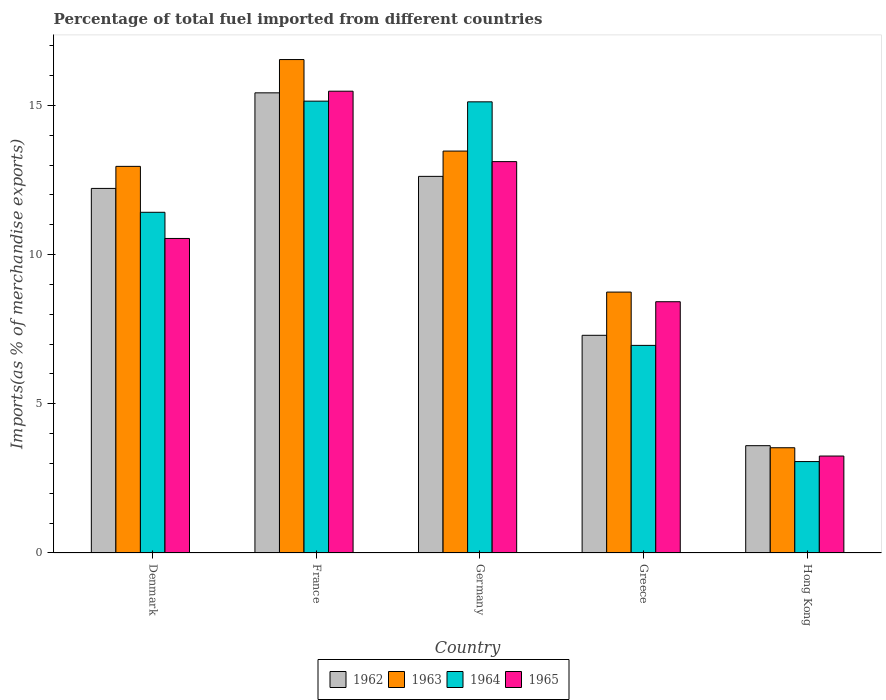How many different coloured bars are there?
Ensure brevity in your answer.  4. How many groups of bars are there?
Provide a succinct answer. 5. Are the number of bars per tick equal to the number of legend labels?
Your answer should be very brief. Yes. What is the label of the 4th group of bars from the left?
Provide a succinct answer. Greece. What is the percentage of imports to different countries in 1962 in Greece?
Your response must be concise. 7.3. Across all countries, what is the maximum percentage of imports to different countries in 1962?
Ensure brevity in your answer.  15.42. Across all countries, what is the minimum percentage of imports to different countries in 1965?
Keep it short and to the point. 3.25. In which country was the percentage of imports to different countries in 1962 maximum?
Provide a short and direct response. France. In which country was the percentage of imports to different countries in 1964 minimum?
Your answer should be very brief. Hong Kong. What is the total percentage of imports to different countries in 1963 in the graph?
Provide a short and direct response. 55.24. What is the difference between the percentage of imports to different countries in 1962 in Denmark and that in Hong Kong?
Your response must be concise. 8.62. What is the difference between the percentage of imports to different countries in 1964 in Greece and the percentage of imports to different countries in 1962 in Germany?
Offer a terse response. -5.66. What is the average percentage of imports to different countries in 1964 per country?
Give a very brief answer. 10.34. What is the difference between the percentage of imports to different countries of/in 1964 and percentage of imports to different countries of/in 1962 in France?
Your answer should be very brief. -0.28. In how many countries, is the percentage of imports to different countries in 1963 greater than 14 %?
Offer a terse response. 1. What is the ratio of the percentage of imports to different countries in 1963 in Greece to that in Hong Kong?
Provide a short and direct response. 2.48. Is the difference between the percentage of imports to different countries in 1964 in Denmark and Greece greater than the difference between the percentage of imports to different countries in 1962 in Denmark and Greece?
Your answer should be very brief. No. What is the difference between the highest and the second highest percentage of imports to different countries in 1964?
Ensure brevity in your answer.  -3.7. What is the difference between the highest and the lowest percentage of imports to different countries in 1962?
Give a very brief answer. 11.83. In how many countries, is the percentage of imports to different countries in 1962 greater than the average percentage of imports to different countries in 1962 taken over all countries?
Ensure brevity in your answer.  3. What does the 3rd bar from the left in Greece represents?
Your answer should be compact. 1964. What does the 2nd bar from the right in Denmark represents?
Give a very brief answer. 1964. Is it the case that in every country, the sum of the percentage of imports to different countries in 1963 and percentage of imports to different countries in 1962 is greater than the percentage of imports to different countries in 1964?
Your answer should be compact. Yes. Are all the bars in the graph horizontal?
Your answer should be very brief. No. Are the values on the major ticks of Y-axis written in scientific E-notation?
Ensure brevity in your answer.  No. Does the graph contain grids?
Your answer should be very brief. No. How many legend labels are there?
Make the answer very short. 4. How are the legend labels stacked?
Your response must be concise. Horizontal. What is the title of the graph?
Make the answer very short. Percentage of total fuel imported from different countries. What is the label or title of the X-axis?
Your response must be concise. Country. What is the label or title of the Y-axis?
Provide a short and direct response. Imports(as % of merchandise exports). What is the Imports(as % of merchandise exports) of 1962 in Denmark?
Your answer should be very brief. 12.22. What is the Imports(as % of merchandise exports) of 1963 in Denmark?
Give a very brief answer. 12.96. What is the Imports(as % of merchandise exports) in 1964 in Denmark?
Your response must be concise. 11.42. What is the Imports(as % of merchandise exports) of 1965 in Denmark?
Your response must be concise. 10.54. What is the Imports(as % of merchandise exports) in 1962 in France?
Provide a succinct answer. 15.42. What is the Imports(as % of merchandise exports) in 1963 in France?
Provide a short and direct response. 16.54. What is the Imports(as % of merchandise exports) in 1964 in France?
Your response must be concise. 15.14. What is the Imports(as % of merchandise exports) of 1965 in France?
Offer a terse response. 15.48. What is the Imports(as % of merchandise exports) of 1962 in Germany?
Make the answer very short. 12.62. What is the Imports(as % of merchandise exports) in 1963 in Germany?
Give a very brief answer. 13.47. What is the Imports(as % of merchandise exports) in 1964 in Germany?
Ensure brevity in your answer.  15.12. What is the Imports(as % of merchandise exports) in 1965 in Germany?
Offer a terse response. 13.12. What is the Imports(as % of merchandise exports) in 1962 in Greece?
Provide a succinct answer. 7.3. What is the Imports(as % of merchandise exports) of 1963 in Greece?
Your response must be concise. 8.74. What is the Imports(as % of merchandise exports) of 1964 in Greece?
Give a very brief answer. 6.96. What is the Imports(as % of merchandise exports) in 1965 in Greece?
Offer a very short reply. 8.42. What is the Imports(as % of merchandise exports) in 1962 in Hong Kong?
Offer a terse response. 3.6. What is the Imports(as % of merchandise exports) of 1963 in Hong Kong?
Ensure brevity in your answer.  3.53. What is the Imports(as % of merchandise exports) of 1964 in Hong Kong?
Provide a succinct answer. 3.06. What is the Imports(as % of merchandise exports) in 1965 in Hong Kong?
Your answer should be very brief. 3.25. Across all countries, what is the maximum Imports(as % of merchandise exports) of 1962?
Provide a short and direct response. 15.42. Across all countries, what is the maximum Imports(as % of merchandise exports) in 1963?
Offer a very short reply. 16.54. Across all countries, what is the maximum Imports(as % of merchandise exports) in 1964?
Your answer should be very brief. 15.14. Across all countries, what is the maximum Imports(as % of merchandise exports) of 1965?
Offer a very short reply. 15.48. Across all countries, what is the minimum Imports(as % of merchandise exports) in 1962?
Your answer should be very brief. 3.6. Across all countries, what is the minimum Imports(as % of merchandise exports) in 1963?
Your response must be concise. 3.53. Across all countries, what is the minimum Imports(as % of merchandise exports) of 1964?
Your answer should be compact. 3.06. Across all countries, what is the minimum Imports(as % of merchandise exports) of 1965?
Offer a terse response. 3.25. What is the total Imports(as % of merchandise exports) in 1962 in the graph?
Make the answer very short. 51.16. What is the total Imports(as % of merchandise exports) of 1963 in the graph?
Ensure brevity in your answer.  55.24. What is the total Imports(as % of merchandise exports) of 1964 in the graph?
Your response must be concise. 51.7. What is the total Imports(as % of merchandise exports) in 1965 in the graph?
Your answer should be compact. 50.81. What is the difference between the Imports(as % of merchandise exports) of 1962 in Denmark and that in France?
Offer a terse response. -3.2. What is the difference between the Imports(as % of merchandise exports) of 1963 in Denmark and that in France?
Your answer should be compact. -3.58. What is the difference between the Imports(as % of merchandise exports) of 1964 in Denmark and that in France?
Your answer should be compact. -3.72. What is the difference between the Imports(as % of merchandise exports) of 1965 in Denmark and that in France?
Offer a terse response. -4.94. What is the difference between the Imports(as % of merchandise exports) in 1962 in Denmark and that in Germany?
Your response must be concise. -0.4. What is the difference between the Imports(as % of merchandise exports) in 1963 in Denmark and that in Germany?
Offer a very short reply. -0.51. What is the difference between the Imports(as % of merchandise exports) in 1964 in Denmark and that in Germany?
Provide a succinct answer. -3.7. What is the difference between the Imports(as % of merchandise exports) in 1965 in Denmark and that in Germany?
Your response must be concise. -2.58. What is the difference between the Imports(as % of merchandise exports) of 1962 in Denmark and that in Greece?
Your answer should be very brief. 4.92. What is the difference between the Imports(as % of merchandise exports) in 1963 in Denmark and that in Greece?
Provide a short and direct response. 4.21. What is the difference between the Imports(as % of merchandise exports) of 1964 in Denmark and that in Greece?
Give a very brief answer. 4.46. What is the difference between the Imports(as % of merchandise exports) in 1965 in Denmark and that in Greece?
Make the answer very short. 2.12. What is the difference between the Imports(as % of merchandise exports) of 1962 in Denmark and that in Hong Kong?
Provide a short and direct response. 8.62. What is the difference between the Imports(as % of merchandise exports) in 1963 in Denmark and that in Hong Kong?
Offer a terse response. 9.43. What is the difference between the Imports(as % of merchandise exports) in 1964 in Denmark and that in Hong Kong?
Your answer should be compact. 8.36. What is the difference between the Imports(as % of merchandise exports) in 1965 in Denmark and that in Hong Kong?
Provide a short and direct response. 7.29. What is the difference between the Imports(as % of merchandise exports) of 1962 in France and that in Germany?
Make the answer very short. 2.8. What is the difference between the Imports(as % of merchandise exports) in 1963 in France and that in Germany?
Make the answer very short. 3.07. What is the difference between the Imports(as % of merchandise exports) of 1964 in France and that in Germany?
Keep it short and to the point. 0.02. What is the difference between the Imports(as % of merchandise exports) of 1965 in France and that in Germany?
Offer a very short reply. 2.36. What is the difference between the Imports(as % of merchandise exports) of 1962 in France and that in Greece?
Give a very brief answer. 8.13. What is the difference between the Imports(as % of merchandise exports) in 1963 in France and that in Greece?
Make the answer very short. 7.79. What is the difference between the Imports(as % of merchandise exports) of 1964 in France and that in Greece?
Keep it short and to the point. 8.19. What is the difference between the Imports(as % of merchandise exports) of 1965 in France and that in Greece?
Your answer should be compact. 7.06. What is the difference between the Imports(as % of merchandise exports) of 1962 in France and that in Hong Kong?
Give a very brief answer. 11.83. What is the difference between the Imports(as % of merchandise exports) in 1963 in France and that in Hong Kong?
Offer a very short reply. 13.01. What is the difference between the Imports(as % of merchandise exports) in 1964 in France and that in Hong Kong?
Ensure brevity in your answer.  12.08. What is the difference between the Imports(as % of merchandise exports) in 1965 in France and that in Hong Kong?
Your answer should be compact. 12.23. What is the difference between the Imports(as % of merchandise exports) in 1962 in Germany and that in Greece?
Ensure brevity in your answer.  5.33. What is the difference between the Imports(as % of merchandise exports) in 1963 in Germany and that in Greece?
Your answer should be compact. 4.73. What is the difference between the Imports(as % of merchandise exports) in 1964 in Germany and that in Greece?
Your answer should be compact. 8.16. What is the difference between the Imports(as % of merchandise exports) of 1965 in Germany and that in Greece?
Your answer should be very brief. 4.7. What is the difference between the Imports(as % of merchandise exports) in 1962 in Germany and that in Hong Kong?
Your answer should be very brief. 9.03. What is the difference between the Imports(as % of merchandise exports) of 1963 in Germany and that in Hong Kong?
Provide a short and direct response. 9.94. What is the difference between the Imports(as % of merchandise exports) of 1964 in Germany and that in Hong Kong?
Ensure brevity in your answer.  12.06. What is the difference between the Imports(as % of merchandise exports) of 1965 in Germany and that in Hong Kong?
Keep it short and to the point. 9.87. What is the difference between the Imports(as % of merchandise exports) in 1962 in Greece and that in Hong Kong?
Your answer should be very brief. 3.7. What is the difference between the Imports(as % of merchandise exports) in 1963 in Greece and that in Hong Kong?
Provide a short and direct response. 5.22. What is the difference between the Imports(as % of merchandise exports) of 1964 in Greece and that in Hong Kong?
Ensure brevity in your answer.  3.89. What is the difference between the Imports(as % of merchandise exports) of 1965 in Greece and that in Hong Kong?
Give a very brief answer. 5.17. What is the difference between the Imports(as % of merchandise exports) in 1962 in Denmark and the Imports(as % of merchandise exports) in 1963 in France?
Offer a very short reply. -4.32. What is the difference between the Imports(as % of merchandise exports) in 1962 in Denmark and the Imports(as % of merchandise exports) in 1964 in France?
Ensure brevity in your answer.  -2.92. What is the difference between the Imports(as % of merchandise exports) of 1962 in Denmark and the Imports(as % of merchandise exports) of 1965 in France?
Provide a short and direct response. -3.26. What is the difference between the Imports(as % of merchandise exports) in 1963 in Denmark and the Imports(as % of merchandise exports) in 1964 in France?
Offer a very short reply. -2.19. What is the difference between the Imports(as % of merchandise exports) of 1963 in Denmark and the Imports(as % of merchandise exports) of 1965 in France?
Keep it short and to the point. -2.52. What is the difference between the Imports(as % of merchandise exports) of 1964 in Denmark and the Imports(as % of merchandise exports) of 1965 in France?
Keep it short and to the point. -4.06. What is the difference between the Imports(as % of merchandise exports) in 1962 in Denmark and the Imports(as % of merchandise exports) in 1963 in Germany?
Your answer should be compact. -1.25. What is the difference between the Imports(as % of merchandise exports) in 1962 in Denmark and the Imports(as % of merchandise exports) in 1964 in Germany?
Your response must be concise. -2.9. What is the difference between the Imports(as % of merchandise exports) in 1962 in Denmark and the Imports(as % of merchandise exports) in 1965 in Germany?
Make the answer very short. -0.9. What is the difference between the Imports(as % of merchandise exports) of 1963 in Denmark and the Imports(as % of merchandise exports) of 1964 in Germany?
Give a very brief answer. -2.16. What is the difference between the Imports(as % of merchandise exports) of 1963 in Denmark and the Imports(as % of merchandise exports) of 1965 in Germany?
Your answer should be compact. -0.16. What is the difference between the Imports(as % of merchandise exports) of 1964 in Denmark and the Imports(as % of merchandise exports) of 1965 in Germany?
Provide a succinct answer. -1.7. What is the difference between the Imports(as % of merchandise exports) in 1962 in Denmark and the Imports(as % of merchandise exports) in 1963 in Greece?
Your answer should be compact. 3.48. What is the difference between the Imports(as % of merchandise exports) in 1962 in Denmark and the Imports(as % of merchandise exports) in 1964 in Greece?
Make the answer very short. 5.26. What is the difference between the Imports(as % of merchandise exports) of 1962 in Denmark and the Imports(as % of merchandise exports) of 1965 in Greece?
Your response must be concise. 3.8. What is the difference between the Imports(as % of merchandise exports) of 1963 in Denmark and the Imports(as % of merchandise exports) of 1964 in Greece?
Offer a terse response. 6. What is the difference between the Imports(as % of merchandise exports) of 1963 in Denmark and the Imports(as % of merchandise exports) of 1965 in Greece?
Offer a terse response. 4.54. What is the difference between the Imports(as % of merchandise exports) in 1964 in Denmark and the Imports(as % of merchandise exports) in 1965 in Greece?
Your answer should be very brief. 3. What is the difference between the Imports(as % of merchandise exports) of 1962 in Denmark and the Imports(as % of merchandise exports) of 1963 in Hong Kong?
Provide a short and direct response. 8.69. What is the difference between the Imports(as % of merchandise exports) of 1962 in Denmark and the Imports(as % of merchandise exports) of 1964 in Hong Kong?
Keep it short and to the point. 9.16. What is the difference between the Imports(as % of merchandise exports) in 1962 in Denmark and the Imports(as % of merchandise exports) in 1965 in Hong Kong?
Give a very brief answer. 8.97. What is the difference between the Imports(as % of merchandise exports) of 1963 in Denmark and the Imports(as % of merchandise exports) of 1964 in Hong Kong?
Your answer should be very brief. 9.89. What is the difference between the Imports(as % of merchandise exports) in 1963 in Denmark and the Imports(as % of merchandise exports) in 1965 in Hong Kong?
Your answer should be compact. 9.71. What is the difference between the Imports(as % of merchandise exports) of 1964 in Denmark and the Imports(as % of merchandise exports) of 1965 in Hong Kong?
Keep it short and to the point. 8.17. What is the difference between the Imports(as % of merchandise exports) in 1962 in France and the Imports(as % of merchandise exports) in 1963 in Germany?
Provide a succinct answer. 1.95. What is the difference between the Imports(as % of merchandise exports) of 1962 in France and the Imports(as % of merchandise exports) of 1964 in Germany?
Provide a succinct answer. 0.3. What is the difference between the Imports(as % of merchandise exports) in 1962 in France and the Imports(as % of merchandise exports) in 1965 in Germany?
Make the answer very short. 2.31. What is the difference between the Imports(as % of merchandise exports) of 1963 in France and the Imports(as % of merchandise exports) of 1964 in Germany?
Ensure brevity in your answer.  1.42. What is the difference between the Imports(as % of merchandise exports) in 1963 in France and the Imports(as % of merchandise exports) in 1965 in Germany?
Make the answer very short. 3.42. What is the difference between the Imports(as % of merchandise exports) of 1964 in France and the Imports(as % of merchandise exports) of 1965 in Germany?
Offer a terse response. 2.03. What is the difference between the Imports(as % of merchandise exports) of 1962 in France and the Imports(as % of merchandise exports) of 1963 in Greece?
Offer a very short reply. 6.68. What is the difference between the Imports(as % of merchandise exports) in 1962 in France and the Imports(as % of merchandise exports) in 1964 in Greece?
Your answer should be compact. 8.46. What is the difference between the Imports(as % of merchandise exports) of 1962 in France and the Imports(as % of merchandise exports) of 1965 in Greece?
Your answer should be very brief. 7. What is the difference between the Imports(as % of merchandise exports) of 1963 in France and the Imports(as % of merchandise exports) of 1964 in Greece?
Provide a short and direct response. 9.58. What is the difference between the Imports(as % of merchandise exports) in 1963 in France and the Imports(as % of merchandise exports) in 1965 in Greece?
Your response must be concise. 8.12. What is the difference between the Imports(as % of merchandise exports) of 1964 in France and the Imports(as % of merchandise exports) of 1965 in Greece?
Give a very brief answer. 6.72. What is the difference between the Imports(as % of merchandise exports) in 1962 in France and the Imports(as % of merchandise exports) in 1963 in Hong Kong?
Make the answer very short. 11.89. What is the difference between the Imports(as % of merchandise exports) in 1962 in France and the Imports(as % of merchandise exports) in 1964 in Hong Kong?
Your answer should be very brief. 12.36. What is the difference between the Imports(as % of merchandise exports) in 1962 in France and the Imports(as % of merchandise exports) in 1965 in Hong Kong?
Offer a very short reply. 12.17. What is the difference between the Imports(as % of merchandise exports) of 1963 in France and the Imports(as % of merchandise exports) of 1964 in Hong Kong?
Make the answer very short. 13.47. What is the difference between the Imports(as % of merchandise exports) of 1963 in France and the Imports(as % of merchandise exports) of 1965 in Hong Kong?
Ensure brevity in your answer.  13.29. What is the difference between the Imports(as % of merchandise exports) of 1964 in France and the Imports(as % of merchandise exports) of 1965 in Hong Kong?
Provide a succinct answer. 11.89. What is the difference between the Imports(as % of merchandise exports) of 1962 in Germany and the Imports(as % of merchandise exports) of 1963 in Greece?
Offer a terse response. 3.88. What is the difference between the Imports(as % of merchandise exports) in 1962 in Germany and the Imports(as % of merchandise exports) in 1964 in Greece?
Keep it short and to the point. 5.66. What is the difference between the Imports(as % of merchandise exports) of 1962 in Germany and the Imports(as % of merchandise exports) of 1965 in Greece?
Make the answer very short. 4.2. What is the difference between the Imports(as % of merchandise exports) of 1963 in Germany and the Imports(as % of merchandise exports) of 1964 in Greece?
Offer a terse response. 6.51. What is the difference between the Imports(as % of merchandise exports) in 1963 in Germany and the Imports(as % of merchandise exports) in 1965 in Greece?
Provide a short and direct response. 5.05. What is the difference between the Imports(as % of merchandise exports) in 1964 in Germany and the Imports(as % of merchandise exports) in 1965 in Greece?
Provide a succinct answer. 6.7. What is the difference between the Imports(as % of merchandise exports) in 1962 in Germany and the Imports(as % of merchandise exports) in 1963 in Hong Kong?
Provide a short and direct response. 9.1. What is the difference between the Imports(as % of merchandise exports) of 1962 in Germany and the Imports(as % of merchandise exports) of 1964 in Hong Kong?
Make the answer very short. 9.56. What is the difference between the Imports(as % of merchandise exports) of 1962 in Germany and the Imports(as % of merchandise exports) of 1965 in Hong Kong?
Offer a terse response. 9.37. What is the difference between the Imports(as % of merchandise exports) in 1963 in Germany and the Imports(as % of merchandise exports) in 1964 in Hong Kong?
Offer a terse response. 10.41. What is the difference between the Imports(as % of merchandise exports) of 1963 in Germany and the Imports(as % of merchandise exports) of 1965 in Hong Kong?
Your answer should be compact. 10.22. What is the difference between the Imports(as % of merchandise exports) of 1964 in Germany and the Imports(as % of merchandise exports) of 1965 in Hong Kong?
Give a very brief answer. 11.87. What is the difference between the Imports(as % of merchandise exports) of 1962 in Greece and the Imports(as % of merchandise exports) of 1963 in Hong Kong?
Provide a succinct answer. 3.77. What is the difference between the Imports(as % of merchandise exports) in 1962 in Greece and the Imports(as % of merchandise exports) in 1964 in Hong Kong?
Ensure brevity in your answer.  4.23. What is the difference between the Imports(as % of merchandise exports) in 1962 in Greece and the Imports(as % of merchandise exports) in 1965 in Hong Kong?
Ensure brevity in your answer.  4.05. What is the difference between the Imports(as % of merchandise exports) in 1963 in Greece and the Imports(as % of merchandise exports) in 1964 in Hong Kong?
Your answer should be very brief. 5.68. What is the difference between the Imports(as % of merchandise exports) in 1963 in Greece and the Imports(as % of merchandise exports) in 1965 in Hong Kong?
Provide a succinct answer. 5.49. What is the difference between the Imports(as % of merchandise exports) of 1964 in Greece and the Imports(as % of merchandise exports) of 1965 in Hong Kong?
Ensure brevity in your answer.  3.71. What is the average Imports(as % of merchandise exports) in 1962 per country?
Offer a terse response. 10.23. What is the average Imports(as % of merchandise exports) in 1963 per country?
Provide a short and direct response. 11.05. What is the average Imports(as % of merchandise exports) of 1964 per country?
Keep it short and to the point. 10.34. What is the average Imports(as % of merchandise exports) in 1965 per country?
Your answer should be very brief. 10.16. What is the difference between the Imports(as % of merchandise exports) of 1962 and Imports(as % of merchandise exports) of 1963 in Denmark?
Offer a terse response. -0.74. What is the difference between the Imports(as % of merchandise exports) in 1962 and Imports(as % of merchandise exports) in 1964 in Denmark?
Offer a terse response. 0.8. What is the difference between the Imports(as % of merchandise exports) of 1962 and Imports(as % of merchandise exports) of 1965 in Denmark?
Ensure brevity in your answer.  1.68. What is the difference between the Imports(as % of merchandise exports) of 1963 and Imports(as % of merchandise exports) of 1964 in Denmark?
Keep it short and to the point. 1.54. What is the difference between the Imports(as % of merchandise exports) of 1963 and Imports(as % of merchandise exports) of 1965 in Denmark?
Provide a succinct answer. 2.42. What is the difference between the Imports(as % of merchandise exports) of 1964 and Imports(as % of merchandise exports) of 1965 in Denmark?
Give a very brief answer. 0.88. What is the difference between the Imports(as % of merchandise exports) of 1962 and Imports(as % of merchandise exports) of 1963 in France?
Your answer should be very brief. -1.12. What is the difference between the Imports(as % of merchandise exports) in 1962 and Imports(as % of merchandise exports) in 1964 in France?
Your answer should be very brief. 0.28. What is the difference between the Imports(as % of merchandise exports) in 1962 and Imports(as % of merchandise exports) in 1965 in France?
Your response must be concise. -0.05. What is the difference between the Imports(as % of merchandise exports) of 1963 and Imports(as % of merchandise exports) of 1964 in France?
Give a very brief answer. 1.39. What is the difference between the Imports(as % of merchandise exports) in 1963 and Imports(as % of merchandise exports) in 1965 in France?
Offer a terse response. 1.06. What is the difference between the Imports(as % of merchandise exports) of 1964 and Imports(as % of merchandise exports) of 1965 in France?
Keep it short and to the point. -0.33. What is the difference between the Imports(as % of merchandise exports) in 1962 and Imports(as % of merchandise exports) in 1963 in Germany?
Offer a very short reply. -0.85. What is the difference between the Imports(as % of merchandise exports) in 1962 and Imports(as % of merchandise exports) in 1964 in Germany?
Offer a very short reply. -2.5. What is the difference between the Imports(as % of merchandise exports) of 1962 and Imports(as % of merchandise exports) of 1965 in Germany?
Give a very brief answer. -0.49. What is the difference between the Imports(as % of merchandise exports) of 1963 and Imports(as % of merchandise exports) of 1964 in Germany?
Make the answer very short. -1.65. What is the difference between the Imports(as % of merchandise exports) of 1963 and Imports(as % of merchandise exports) of 1965 in Germany?
Give a very brief answer. 0.35. What is the difference between the Imports(as % of merchandise exports) of 1964 and Imports(as % of merchandise exports) of 1965 in Germany?
Offer a terse response. 2. What is the difference between the Imports(as % of merchandise exports) in 1962 and Imports(as % of merchandise exports) in 1963 in Greece?
Make the answer very short. -1.45. What is the difference between the Imports(as % of merchandise exports) of 1962 and Imports(as % of merchandise exports) of 1964 in Greece?
Your response must be concise. 0.34. What is the difference between the Imports(as % of merchandise exports) of 1962 and Imports(as % of merchandise exports) of 1965 in Greece?
Your answer should be compact. -1.13. What is the difference between the Imports(as % of merchandise exports) of 1963 and Imports(as % of merchandise exports) of 1964 in Greece?
Keep it short and to the point. 1.79. What is the difference between the Imports(as % of merchandise exports) in 1963 and Imports(as % of merchandise exports) in 1965 in Greece?
Your response must be concise. 0.32. What is the difference between the Imports(as % of merchandise exports) of 1964 and Imports(as % of merchandise exports) of 1965 in Greece?
Make the answer very short. -1.46. What is the difference between the Imports(as % of merchandise exports) of 1962 and Imports(as % of merchandise exports) of 1963 in Hong Kong?
Offer a very short reply. 0.07. What is the difference between the Imports(as % of merchandise exports) in 1962 and Imports(as % of merchandise exports) in 1964 in Hong Kong?
Your response must be concise. 0.53. What is the difference between the Imports(as % of merchandise exports) in 1962 and Imports(as % of merchandise exports) in 1965 in Hong Kong?
Keep it short and to the point. 0.35. What is the difference between the Imports(as % of merchandise exports) of 1963 and Imports(as % of merchandise exports) of 1964 in Hong Kong?
Make the answer very short. 0.46. What is the difference between the Imports(as % of merchandise exports) of 1963 and Imports(as % of merchandise exports) of 1965 in Hong Kong?
Offer a terse response. 0.28. What is the difference between the Imports(as % of merchandise exports) of 1964 and Imports(as % of merchandise exports) of 1965 in Hong Kong?
Your response must be concise. -0.19. What is the ratio of the Imports(as % of merchandise exports) of 1962 in Denmark to that in France?
Make the answer very short. 0.79. What is the ratio of the Imports(as % of merchandise exports) in 1963 in Denmark to that in France?
Your response must be concise. 0.78. What is the ratio of the Imports(as % of merchandise exports) of 1964 in Denmark to that in France?
Offer a very short reply. 0.75. What is the ratio of the Imports(as % of merchandise exports) in 1965 in Denmark to that in France?
Ensure brevity in your answer.  0.68. What is the ratio of the Imports(as % of merchandise exports) in 1962 in Denmark to that in Germany?
Offer a terse response. 0.97. What is the ratio of the Imports(as % of merchandise exports) in 1963 in Denmark to that in Germany?
Make the answer very short. 0.96. What is the ratio of the Imports(as % of merchandise exports) in 1964 in Denmark to that in Germany?
Your answer should be compact. 0.76. What is the ratio of the Imports(as % of merchandise exports) in 1965 in Denmark to that in Germany?
Provide a succinct answer. 0.8. What is the ratio of the Imports(as % of merchandise exports) of 1962 in Denmark to that in Greece?
Your answer should be very brief. 1.67. What is the ratio of the Imports(as % of merchandise exports) in 1963 in Denmark to that in Greece?
Provide a succinct answer. 1.48. What is the ratio of the Imports(as % of merchandise exports) in 1964 in Denmark to that in Greece?
Provide a short and direct response. 1.64. What is the ratio of the Imports(as % of merchandise exports) of 1965 in Denmark to that in Greece?
Your answer should be very brief. 1.25. What is the ratio of the Imports(as % of merchandise exports) in 1962 in Denmark to that in Hong Kong?
Ensure brevity in your answer.  3.4. What is the ratio of the Imports(as % of merchandise exports) of 1963 in Denmark to that in Hong Kong?
Offer a terse response. 3.67. What is the ratio of the Imports(as % of merchandise exports) in 1964 in Denmark to that in Hong Kong?
Make the answer very short. 3.73. What is the ratio of the Imports(as % of merchandise exports) in 1965 in Denmark to that in Hong Kong?
Make the answer very short. 3.24. What is the ratio of the Imports(as % of merchandise exports) of 1962 in France to that in Germany?
Provide a short and direct response. 1.22. What is the ratio of the Imports(as % of merchandise exports) in 1963 in France to that in Germany?
Your response must be concise. 1.23. What is the ratio of the Imports(as % of merchandise exports) in 1964 in France to that in Germany?
Make the answer very short. 1. What is the ratio of the Imports(as % of merchandise exports) in 1965 in France to that in Germany?
Make the answer very short. 1.18. What is the ratio of the Imports(as % of merchandise exports) of 1962 in France to that in Greece?
Keep it short and to the point. 2.11. What is the ratio of the Imports(as % of merchandise exports) in 1963 in France to that in Greece?
Make the answer very short. 1.89. What is the ratio of the Imports(as % of merchandise exports) in 1964 in France to that in Greece?
Offer a terse response. 2.18. What is the ratio of the Imports(as % of merchandise exports) in 1965 in France to that in Greece?
Give a very brief answer. 1.84. What is the ratio of the Imports(as % of merchandise exports) in 1962 in France to that in Hong Kong?
Give a very brief answer. 4.29. What is the ratio of the Imports(as % of merchandise exports) of 1963 in France to that in Hong Kong?
Offer a terse response. 4.69. What is the ratio of the Imports(as % of merchandise exports) in 1964 in France to that in Hong Kong?
Your answer should be compact. 4.94. What is the ratio of the Imports(as % of merchandise exports) in 1965 in France to that in Hong Kong?
Your answer should be very brief. 4.76. What is the ratio of the Imports(as % of merchandise exports) of 1962 in Germany to that in Greece?
Your response must be concise. 1.73. What is the ratio of the Imports(as % of merchandise exports) of 1963 in Germany to that in Greece?
Give a very brief answer. 1.54. What is the ratio of the Imports(as % of merchandise exports) in 1964 in Germany to that in Greece?
Keep it short and to the point. 2.17. What is the ratio of the Imports(as % of merchandise exports) in 1965 in Germany to that in Greece?
Your response must be concise. 1.56. What is the ratio of the Imports(as % of merchandise exports) in 1962 in Germany to that in Hong Kong?
Give a very brief answer. 3.51. What is the ratio of the Imports(as % of merchandise exports) of 1963 in Germany to that in Hong Kong?
Ensure brevity in your answer.  3.82. What is the ratio of the Imports(as % of merchandise exports) of 1964 in Germany to that in Hong Kong?
Your answer should be compact. 4.94. What is the ratio of the Imports(as % of merchandise exports) in 1965 in Germany to that in Hong Kong?
Keep it short and to the point. 4.04. What is the ratio of the Imports(as % of merchandise exports) in 1962 in Greece to that in Hong Kong?
Offer a very short reply. 2.03. What is the ratio of the Imports(as % of merchandise exports) in 1963 in Greece to that in Hong Kong?
Keep it short and to the point. 2.48. What is the ratio of the Imports(as % of merchandise exports) in 1964 in Greece to that in Hong Kong?
Provide a succinct answer. 2.27. What is the ratio of the Imports(as % of merchandise exports) of 1965 in Greece to that in Hong Kong?
Your answer should be very brief. 2.59. What is the difference between the highest and the second highest Imports(as % of merchandise exports) in 1962?
Your answer should be very brief. 2.8. What is the difference between the highest and the second highest Imports(as % of merchandise exports) of 1963?
Your answer should be compact. 3.07. What is the difference between the highest and the second highest Imports(as % of merchandise exports) of 1964?
Ensure brevity in your answer.  0.02. What is the difference between the highest and the second highest Imports(as % of merchandise exports) of 1965?
Your answer should be compact. 2.36. What is the difference between the highest and the lowest Imports(as % of merchandise exports) in 1962?
Provide a succinct answer. 11.83. What is the difference between the highest and the lowest Imports(as % of merchandise exports) of 1963?
Your answer should be very brief. 13.01. What is the difference between the highest and the lowest Imports(as % of merchandise exports) in 1964?
Offer a very short reply. 12.08. What is the difference between the highest and the lowest Imports(as % of merchandise exports) in 1965?
Provide a succinct answer. 12.23. 